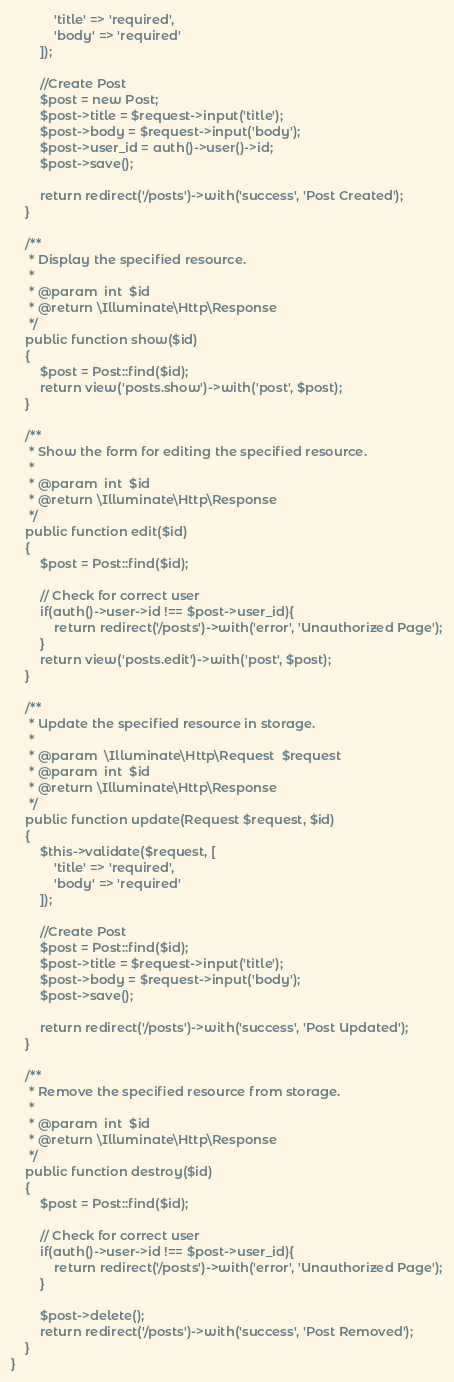<code> <loc_0><loc_0><loc_500><loc_500><_PHP_>            'title' => 'required',
            'body' => 'required'
        ]);

        //Create Post
        $post = new Post;
        $post->title = $request->input('title');
        $post->body = $request->input('body');
        $post->user_id = auth()->user()->id;
        $post->save();

        return redirect('/posts')->with('success', 'Post Created');
    }

    /**
     * Display the specified resource.
     *
     * @param  int  $id
     * @return \Illuminate\Http\Response
     */
    public function show($id)
    {
        $post = Post::find($id);
        return view('posts.show')->with('post', $post);
    }

    /**
     * Show the form for editing the specified resource.
     *
     * @param  int  $id
     * @return \Illuminate\Http\Response
     */
    public function edit($id)
    {
        $post = Post::find($id);

        // Check for correct user
        if(auth()->user->id !== $post->user_id){
            return redirect('/posts')->with('error', 'Unauthorized Page');
        } 
        return view('posts.edit')->with('post', $post);
    }

    /**
     * Update the specified resource in storage.
     *
     * @param  \Illuminate\Http\Request  $request
     * @param  int  $id
     * @return \Illuminate\Http\Response
     */
    public function update(Request $request, $id)
    {
        $this->validate($request, [
            'title' => 'required',
            'body' => 'required'
        ]);

        //Create Post
        $post = Post::find($id);
        $post->title = $request->input('title');
        $post->body = $request->input('body');
        $post->save();

        return redirect('/posts')->with('success', 'Post Updated');
    }

    /**
     * Remove the specified resource from storage.
     *
     * @param  int  $id
     * @return \Illuminate\Http\Response
     */
    public function destroy($id)
    {
        $post = Post::find($id);

        // Check for correct user
        if(auth()->user->id !== $post->user_id){
            return redirect('/posts')->with('error', 'Unauthorized Page');
        } 

        $post->delete();
        return redirect('/posts')->with('success', 'Post Removed');
    }
}
</code> 